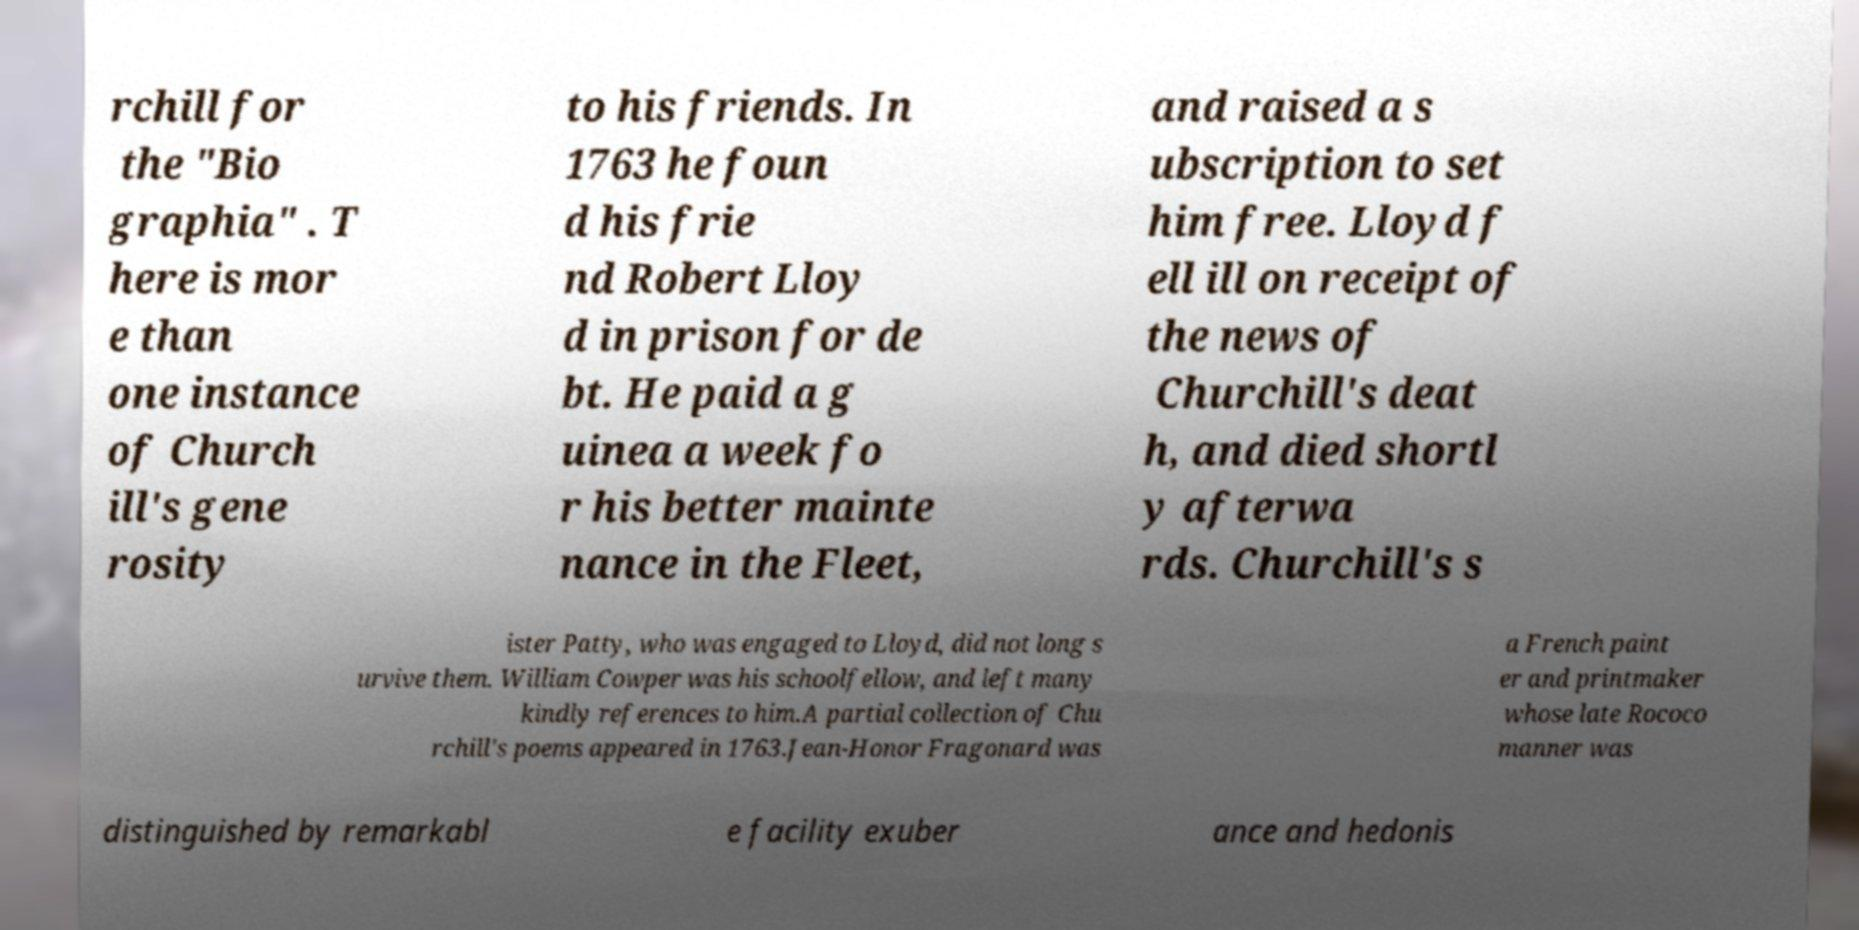Please read and relay the text visible in this image. What does it say? rchill for the "Bio graphia" . T here is mor e than one instance of Church ill's gene rosity to his friends. In 1763 he foun d his frie nd Robert Lloy d in prison for de bt. He paid a g uinea a week fo r his better mainte nance in the Fleet, and raised a s ubscription to set him free. Lloyd f ell ill on receipt of the news of Churchill's deat h, and died shortl y afterwa rds. Churchill's s ister Patty, who was engaged to Lloyd, did not long s urvive them. William Cowper was his schoolfellow, and left many kindly references to him.A partial collection of Chu rchill's poems appeared in 1763.Jean-Honor Fragonard was a French paint er and printmaker whose late Rococo manner was distinguished by remarkabl e facility exuber ance and hedonis 